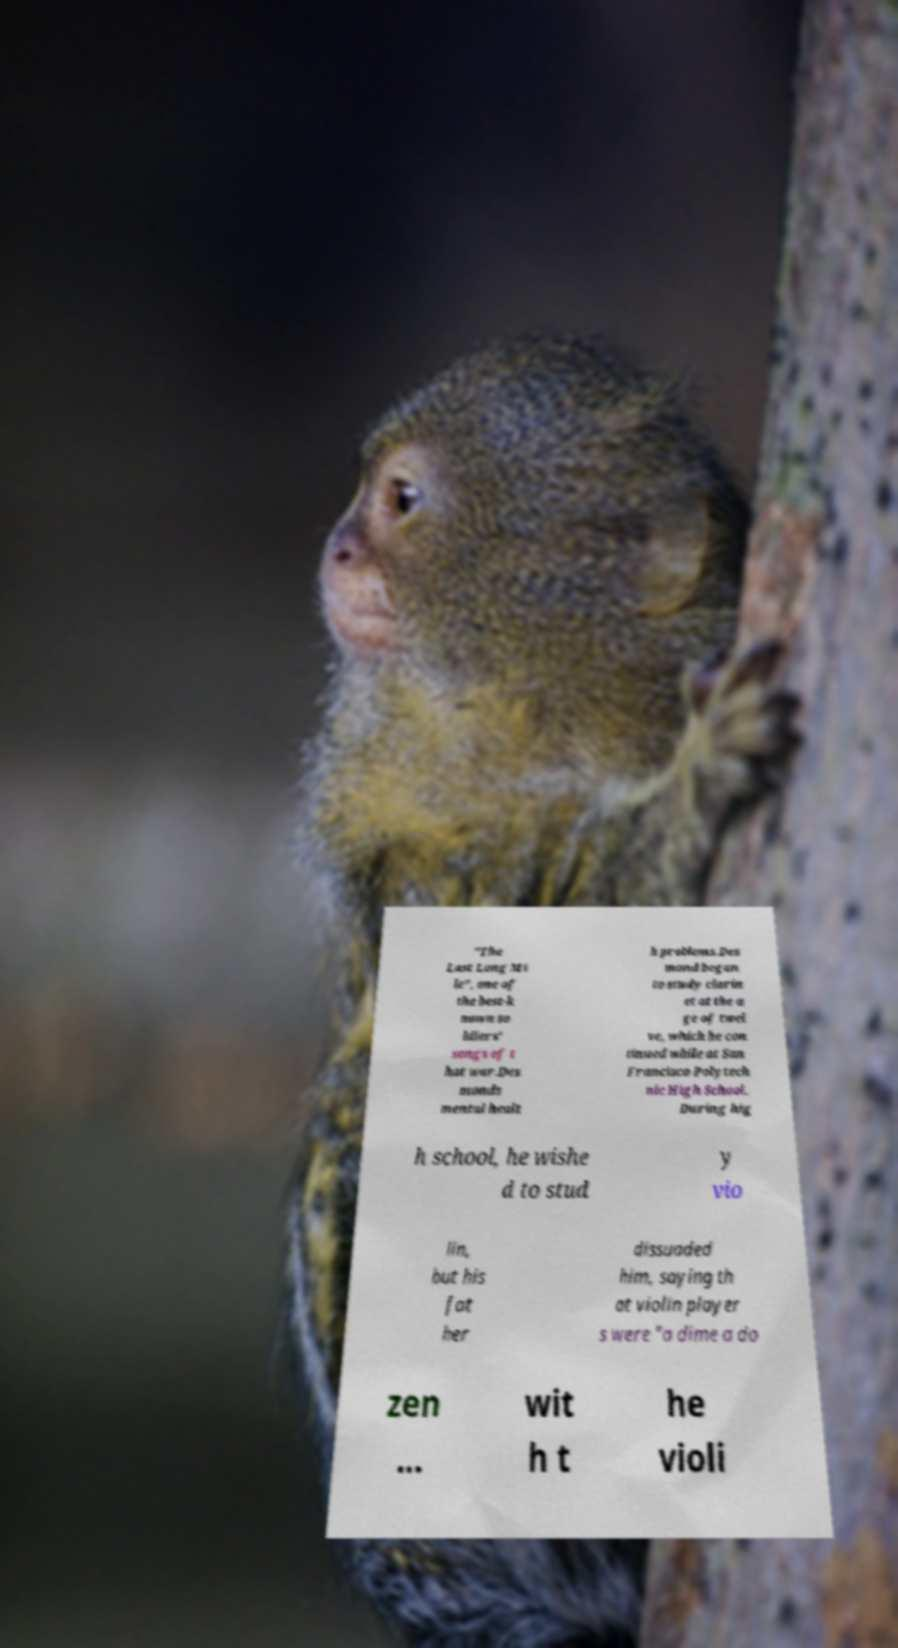Could you assist in decoding the text presented in this image and type it out clearly? "The Last Long Mi le", one of the best-k nown so ldiers' songs of t hat war.Des monds mental healt h problems.Des mond began to study clarin et at the a ge of twel ve, which he con tinued while at San Francisco Polytech nic High School. During hig h school, he wishe d to stud y vio lin, but his fat her dissuaded him, saying th at violin player s were "a dime a do zen ... wit h t he violi 